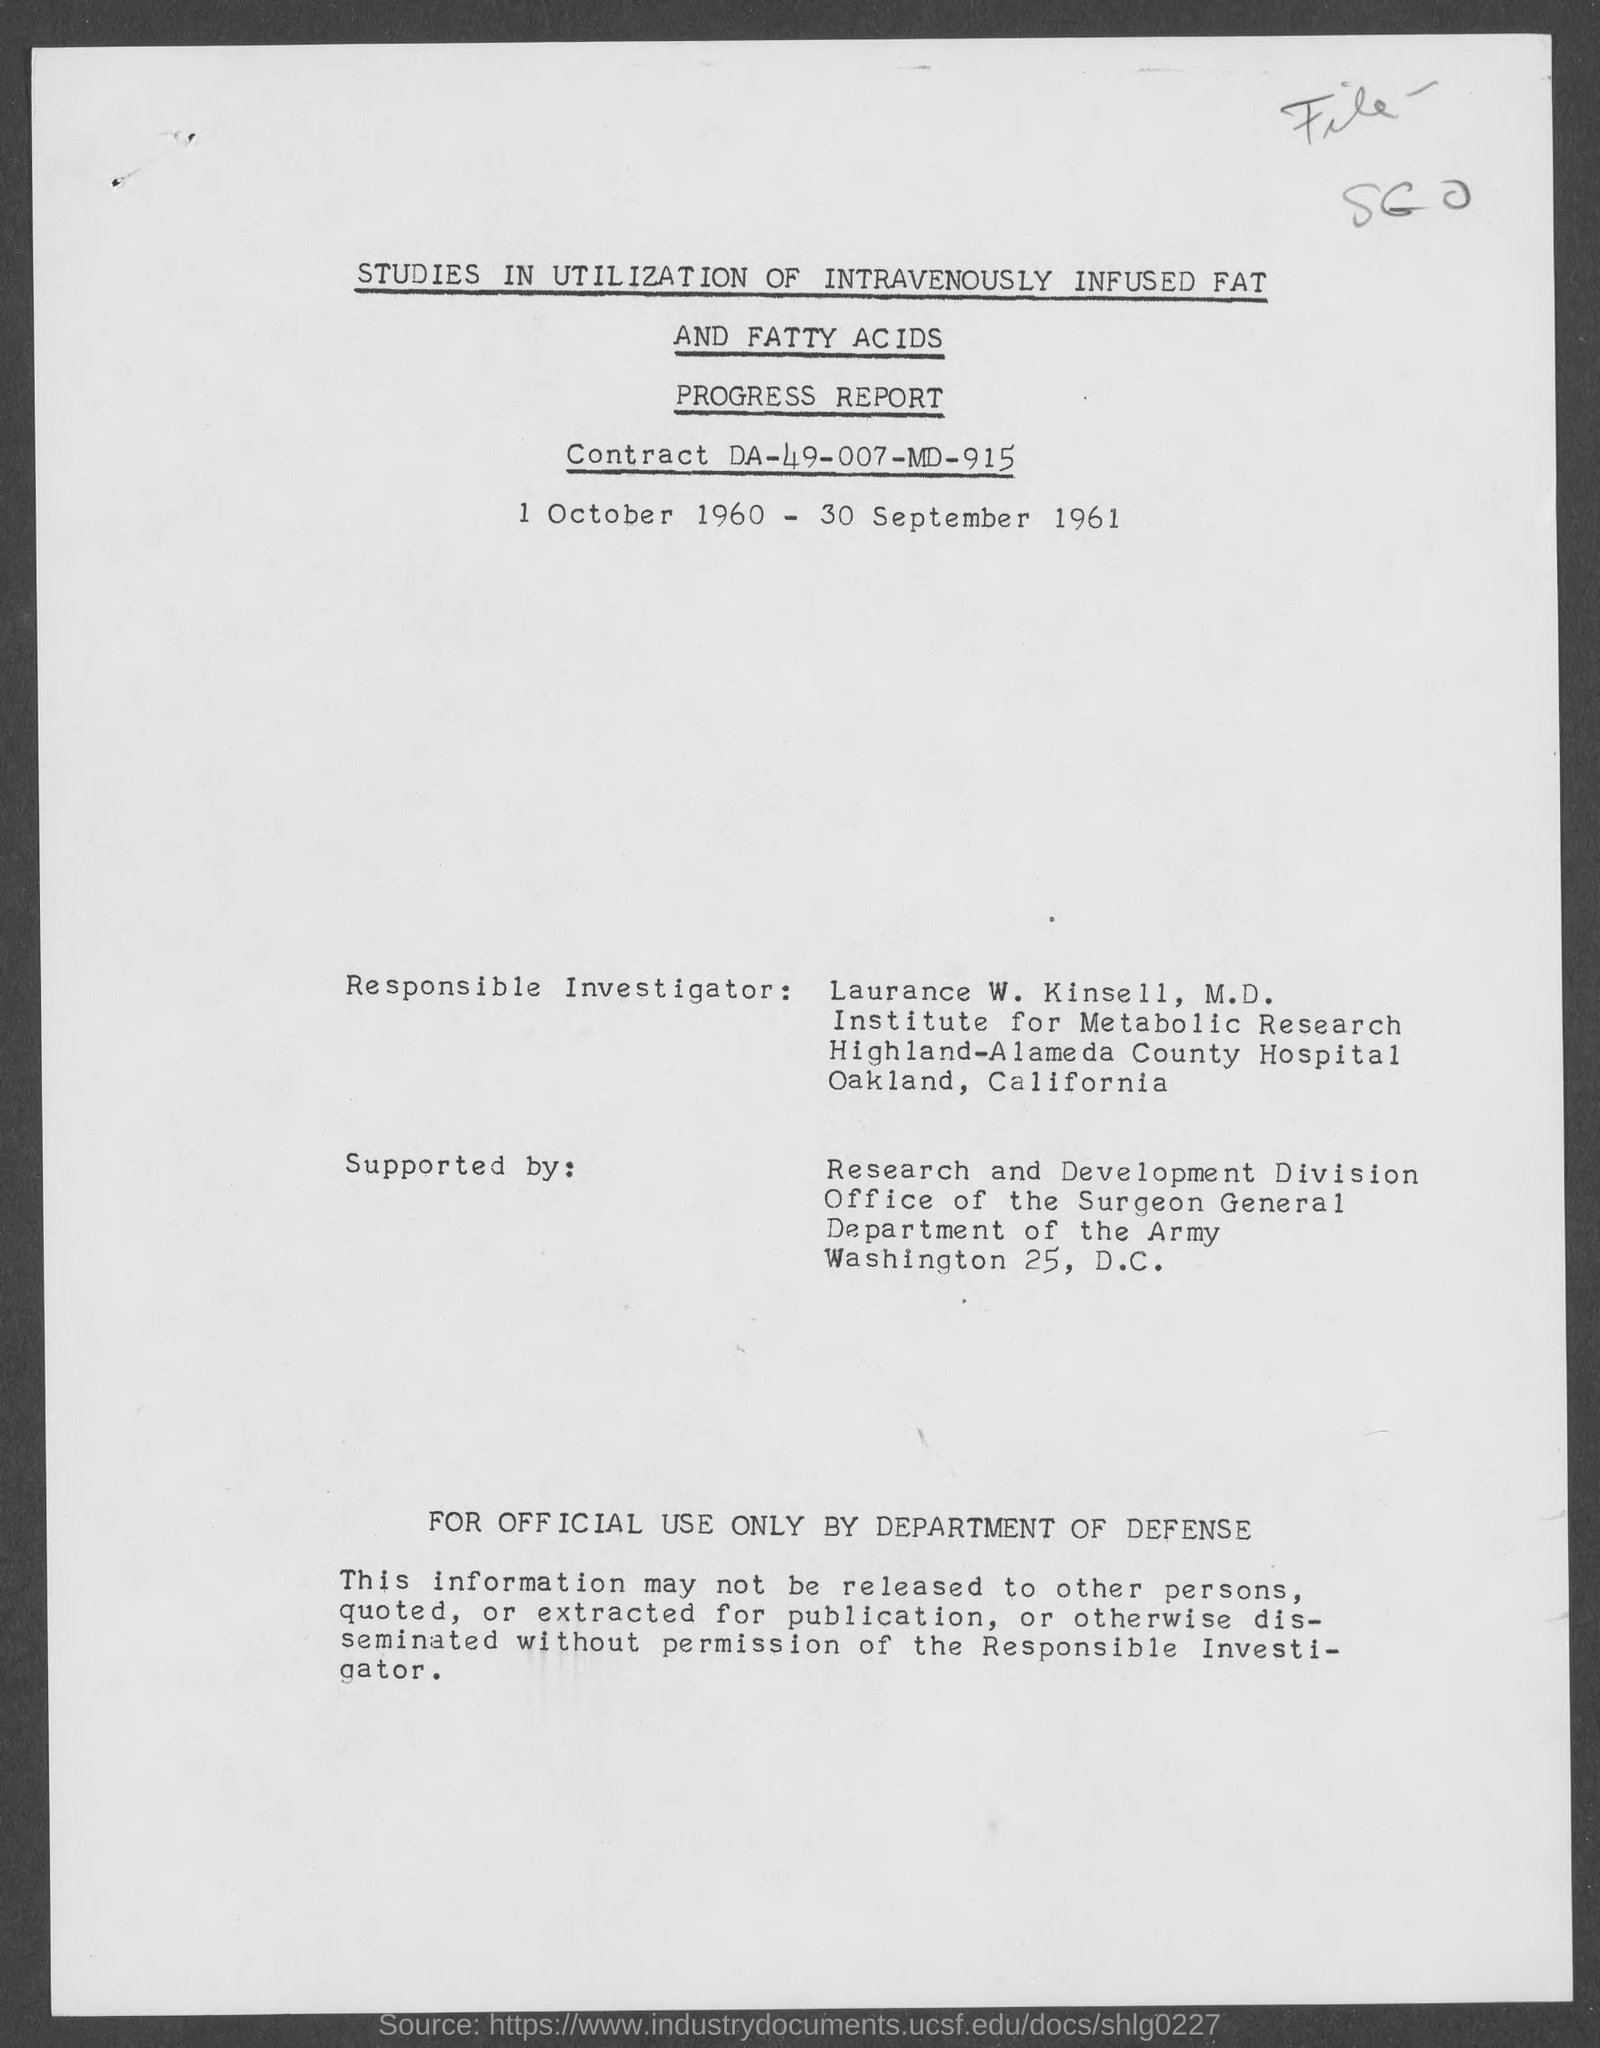What is the contract no.?
Give a very brief answer. DA-49-007-MD-915. 